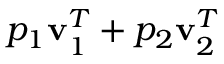<formula> <loc_0><loc_0><loc_500><loc_500>p _ { 1 } v _ { 1 } ^ { T } + p _ { 2 } v _ { 2 } ^ { T }</formula> 